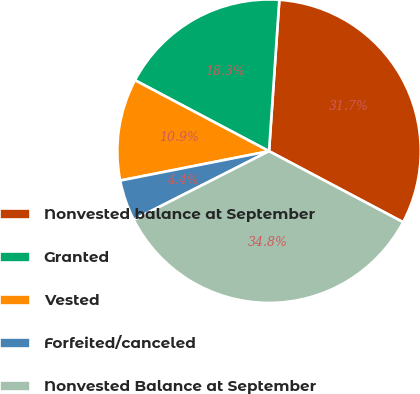Convert chart. <chart><loc_0><loc_0><loc_500><loc_500><pie_chart><fcel>Nonvested balance at September<fcel>Granted<fcel>Vested<fcel>Forfeited/canceled<fcel>Nonvested Balance at September<nl><fcel>31.67%<fcel>18.33%<fcel>10.85%<fcel>4.37%<fcel>34.77%<nl></chart> 